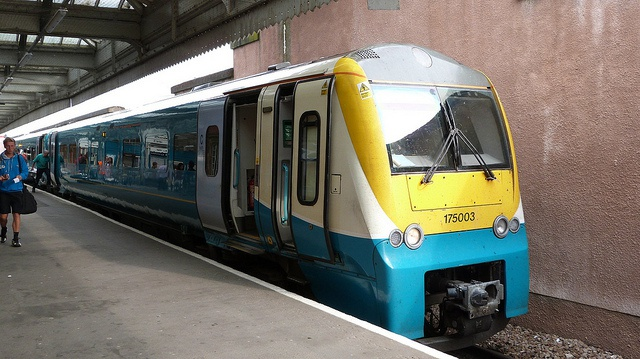Describe the objects in this image and their specific colors. I can see train in black, gray, white, and khaki tones, people in black, blue, navy, and gray tones, people in black, teal, gray, and darkblue tones, handbag in black, gray, navy, and darkblue tones, and people in black tones in this image. 